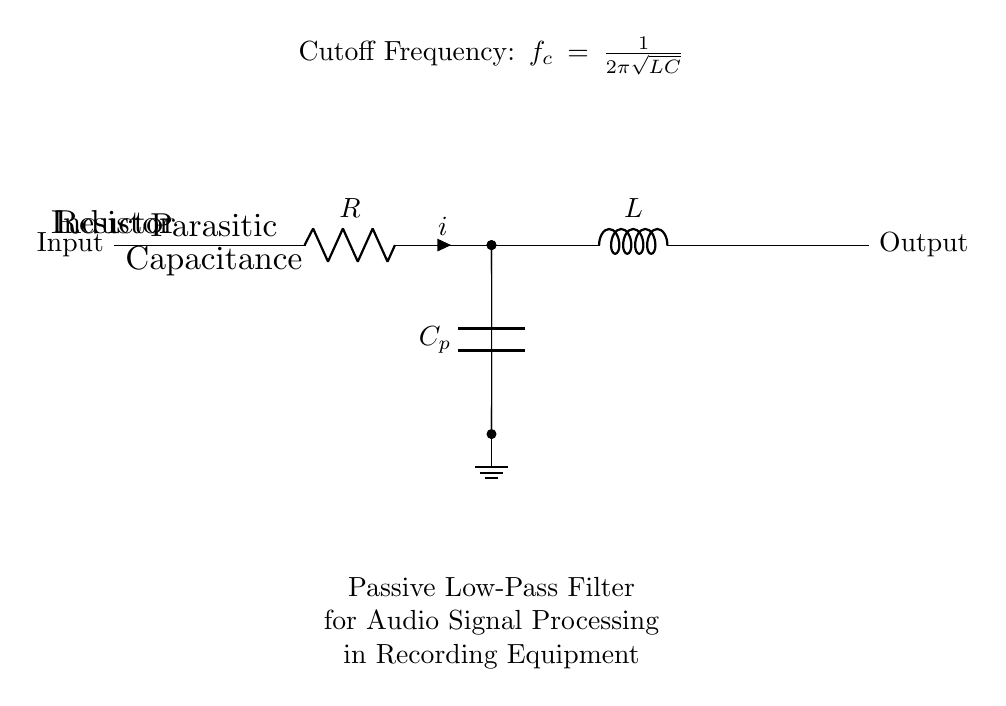What components are in this circuit? The circuit contains a resistor, an inductor, and a parasitic capacitor. These components are identified visually in the diagram where the resistor is labeled R, the inductor is labeled L, and there is a capacitance labeled Cp.
Answer: Resistor, Inductor, Capacitor What is the function of this circuit? The function of this circuit is to act as a passive low-pass filter, which allows lower frequency signals to pass while attenuating higher frequency signals. This information is derived from the circuit description and the inclusion of the resistor and inductor combination, typical of low-pass filters.
Answer: Passive low-pass filter What is the cutoff frequency formula shown in the circuit? The cutoff frequency formula presented is fc = 1/(2π√(LC)). This is stated in the circuit description as the formula to determine the frequency at which the output signal begins to roll off.
Answer: fc = 1/(2π√(LC)) What happens to higher frequency signals when using this circuit? Higher frequency signals are attenuated, meaning their amplitude is reduced significantly. This is the primary purpose of the low-pass filter in the circuit, which is designed to block or diminish signals above the cutoff frequency.
Answer: Attenuated Which component has parasitic capacitance in this circuit diagram? The component with parasitic capacitance in this diagram is the resistor, as indicated by the connection of the parasitic capacitor Cp labeled beneath it. This highlights that all components can exhibit some level of unintended capacitance in practical applications.
Answer: Resistor What is the relationship between resistance, inductance, and the cutoff frequency? The relationship is given by the formula fc = 1/(2π√(LC)), where the cutoff frequency is inversely related to the square root of the product of inductance and capacitance. This means increasing L or C will lower fc, affecting the filter's performance.
Answer: Inversely related 